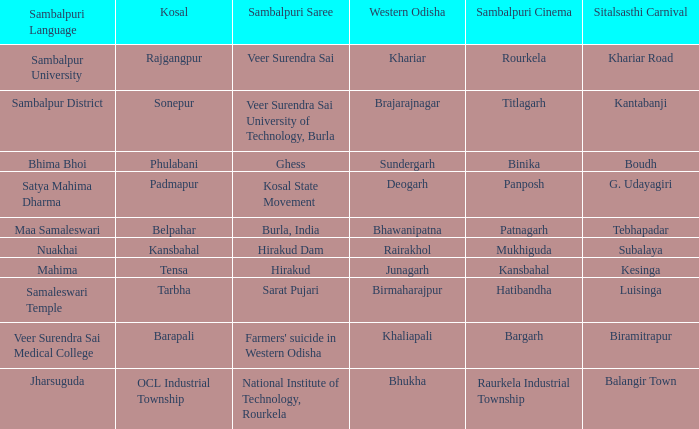What is the sitalsasthi carnival with sonepur as kosal? Kantabanji. 